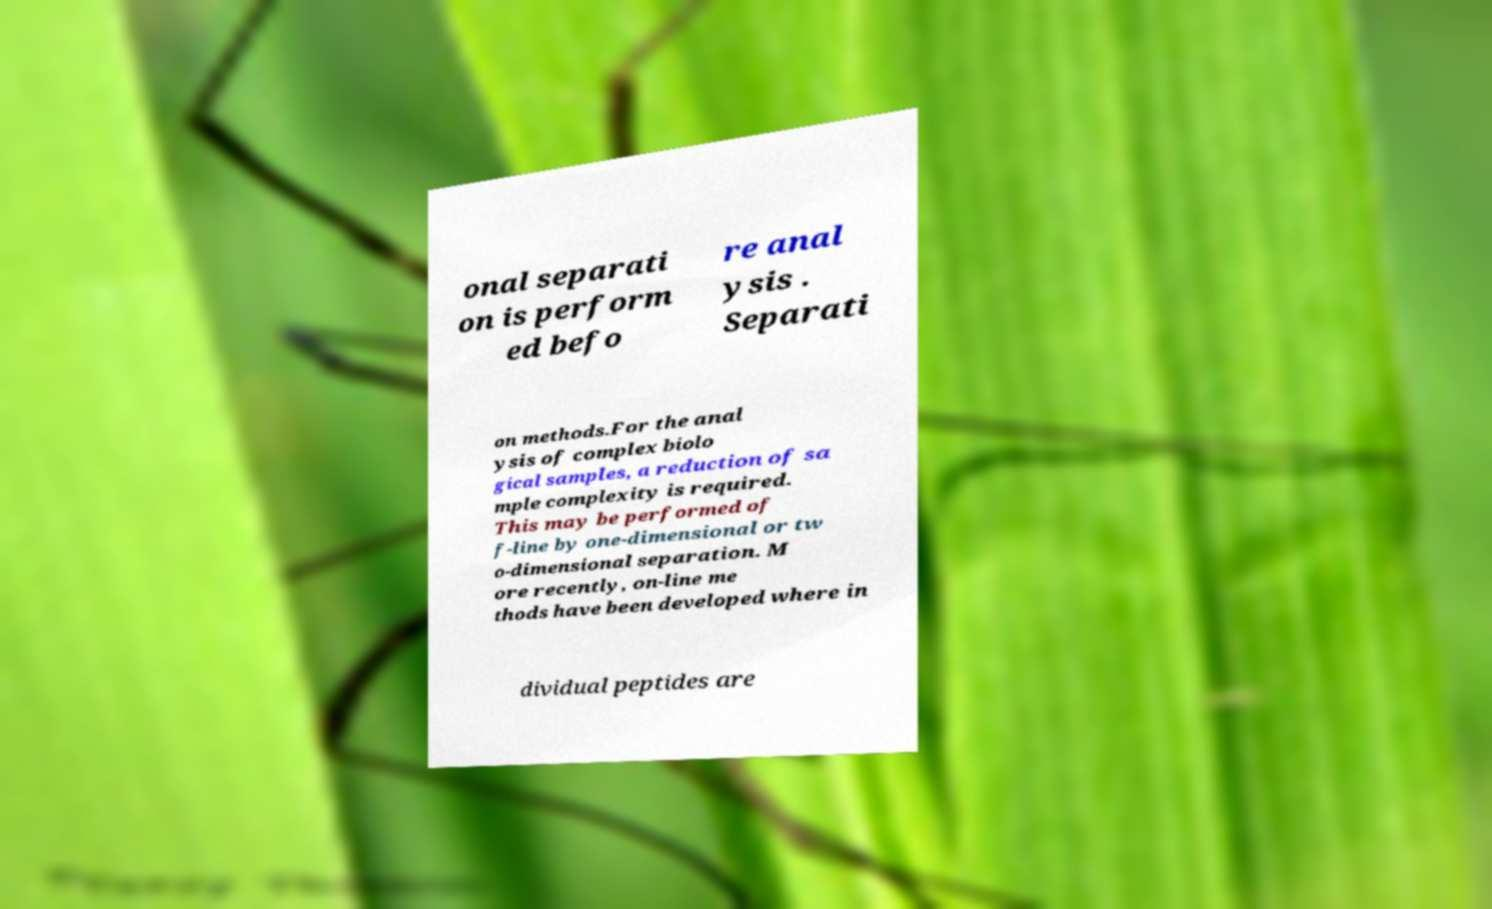What messages or text are displayed in this image? I need them in a readable, typed format. onal separati on is perform ed befo re anal ysis . Separati on methods.For the anal ysis of complex biolo gical samples, a reduction of sa mple complexity is required. This may be performed of f-line by one-dimensional or tw o-dimensional separation. M ore recently, on-line me thods have been developed where in dividual peptides are 